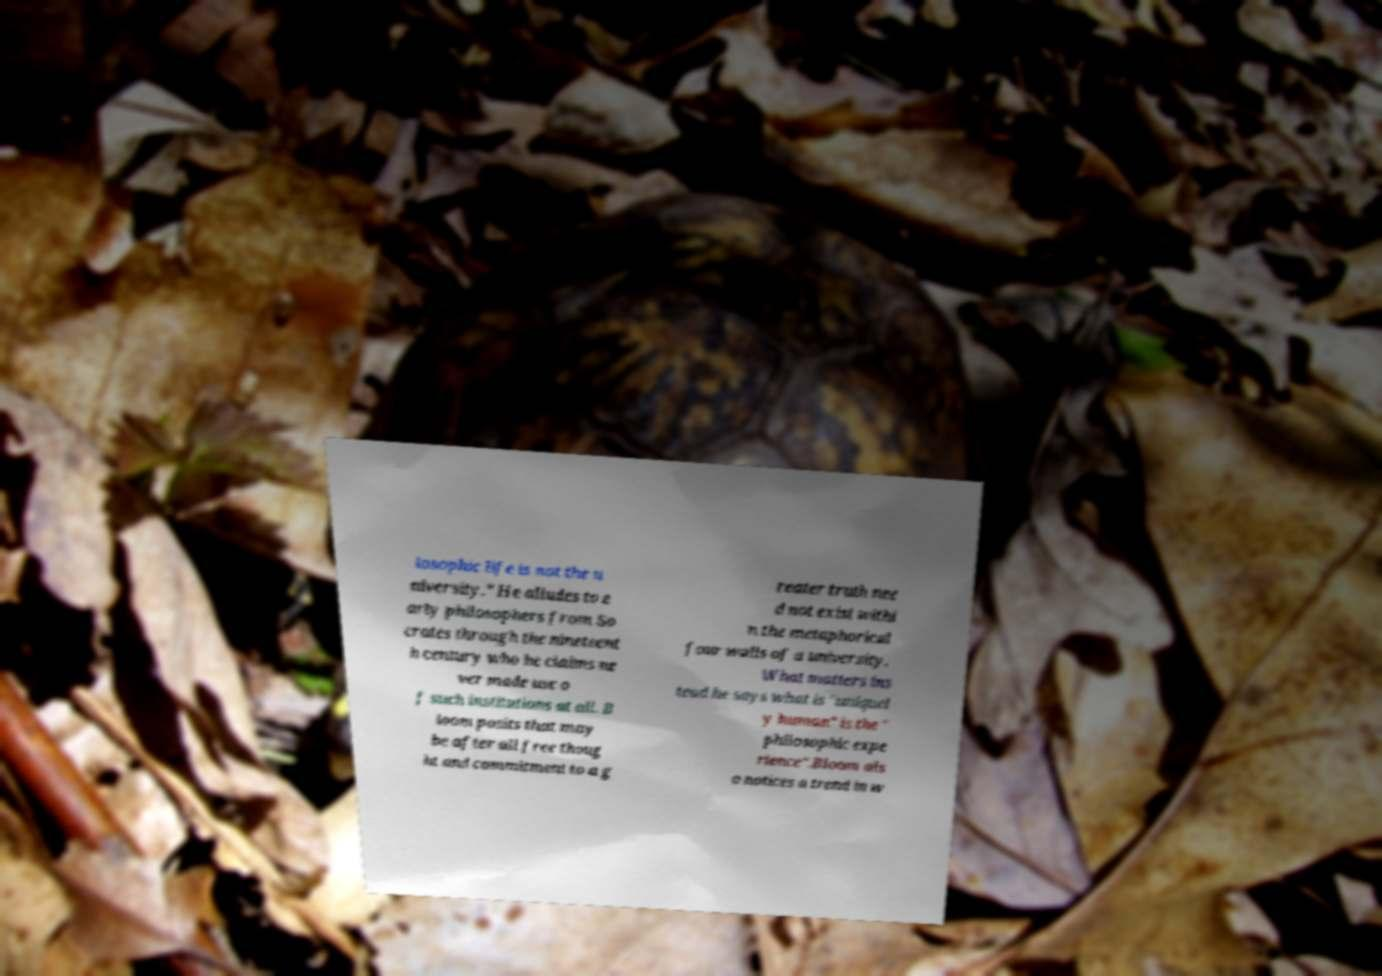I need the written content from this picture converted into text. Can you do that? losophic life is not the u niversity." He alludes to e arly philosophers from So crates through the nineteent h century who he claims ne ver made use o f such institutions at all. B loom posits that may be after all free thoug ht and commitment to a g reater truth nee d not exist withi n the metaphorical four walls of a university. What matters ins tead he says what is "uniquel y human" is the " philosophic expe rience".Bloom als o notices a trend in w 